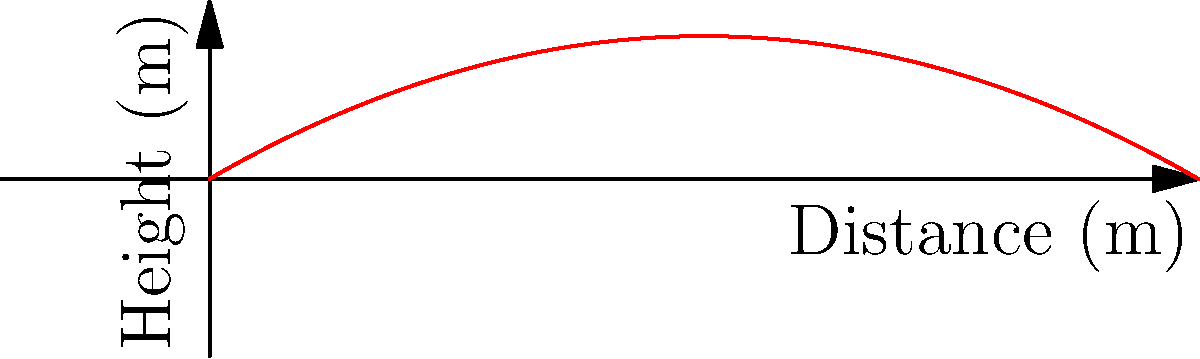As a bounty hunter, you need to intercept a BB unit using a long-range weapon. Given a projectile launched at an initial velocity of 100 m/s at a 30-degree angle from the horizontal, calculate:

a) The maximum range of the projectile
b) The maximum height reached by the projectile

Assume standard gravity (g = 9.8 m/s²) and neglect air resistance. To solve this problem, we'll use the equations of projectile motion:

1. For maximum range (R):
   $$R = \frac{v_0^2 \sin(2\theta)}{g}$$

2. For maximum height (H):
   $$H = \frac{v_0^2 \sin^2(\theta)}{2g}$$

Where:
$v_0$ = initial velocity = 100 m/s
$\theta$ = launch angle = 30°
$g$ = acceleration due to gravity = 9.8 m/s²

a) Maximum range:
   $$R = \frac{(100)^2 \sin(2 \cdot 30°)}{9.8}$$
   $$R = \frac{10000 \cdot \sin(60°)}{9.8}$$
   $$R = \frac{10000 \cdot 0.866}{9.8} \approx 883.67 \text{ m}$$

b) Maximum height:
   $$H = \frac{(100)^2 \sin^2(30°)}{2 \cdot 9.8}$$
   $$H = \frac{10000 \cdot (0.5)^2}{19.6}$$
   $$H = \frac{2500}{19.6} \approx 127.55 \text{ m}$$
Answer: a) 883.67 m
b) 127.55 m 